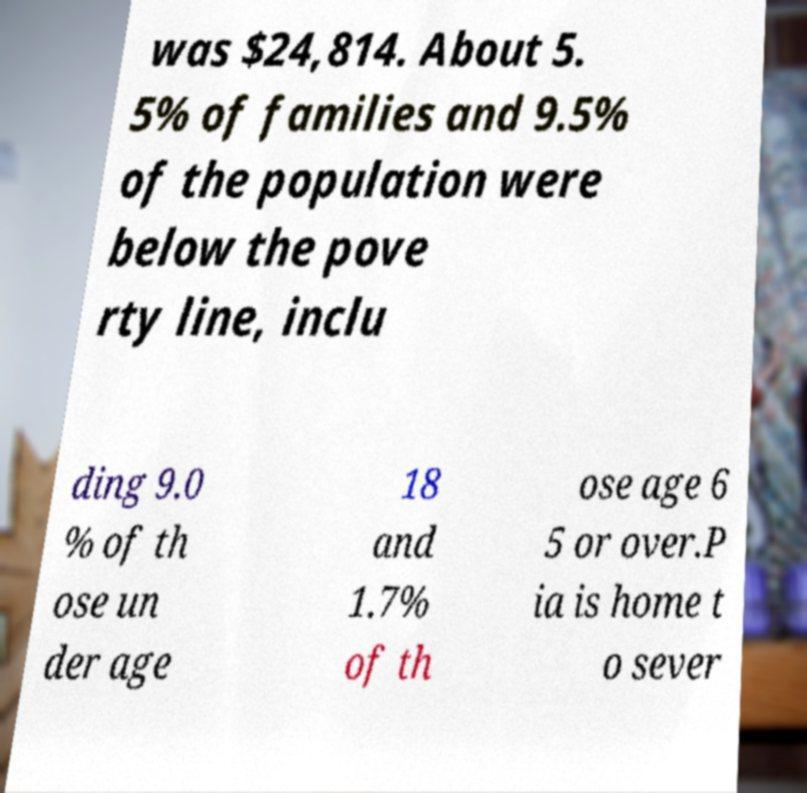What messages or text are displayed in this image? I need them in a readable, typed format. was $24,814. About 5. 5% of families and 9.5% of the population were below the pove rty line, inclu ding 9.0 % of th ose un der age 18 and 1.7% of th ose age 6 5 or over.P ia is home t o sever 